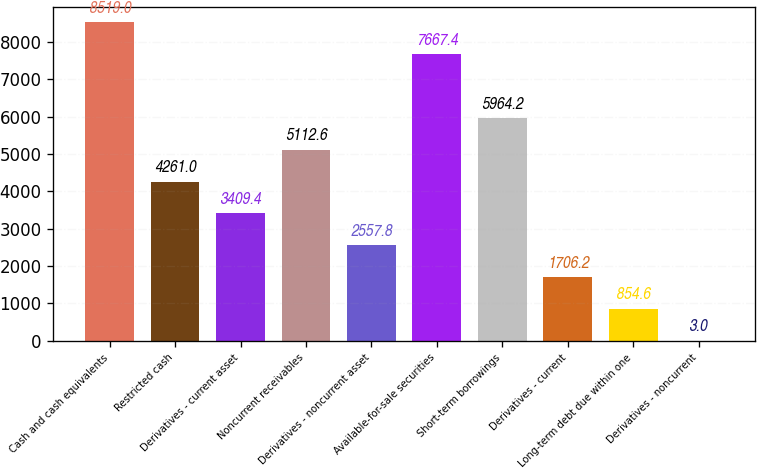Convert chart to OTSL. <chart><loc_0><loc_0><loc_500><loc_500><bar_chart><fcel>Cash and cash equivalents<fcel>Restricted cash<fcel>Derivatives - current asset<fcel>Noncurrent receivables<fcel>Derivatives - noncurrent asset<fcel>Available-for-sale securities<fcel>Short-term borrowings<fcel>Derivatives - current<fcel>Long-term debt due within one<fcel>Derivatives - noncurrent<nl><fcel>8519<fcel>4261<fcel>3409.4<fcel>5112.6<fcel>2557.8<fcel>7667.4<fcel>5964.2<fcel>1706.2<fcel>854.6<fcel>3<nl></chart> 